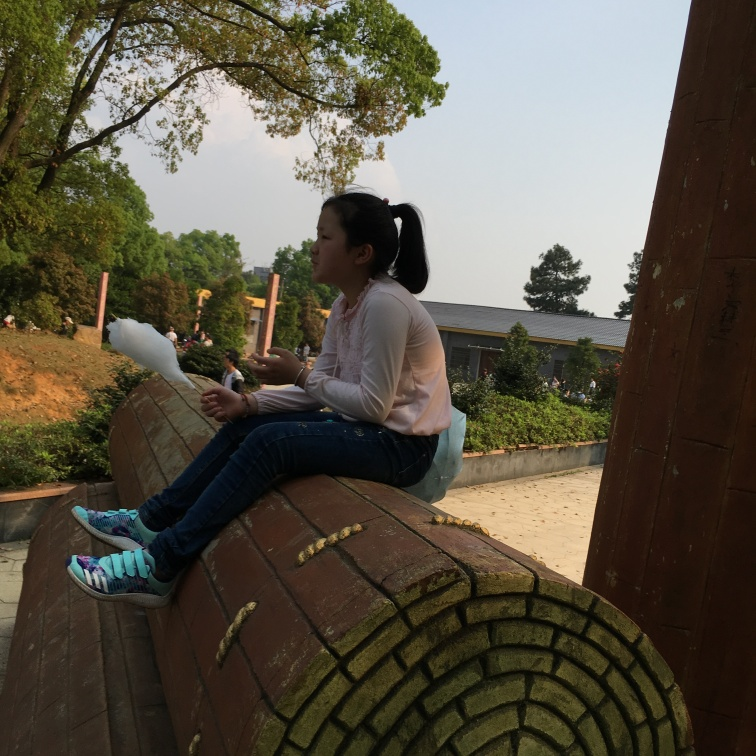What activities might be associated with this location? Given the park-like setting, common activities could include picnicking, leisurely walks, reading, or simply enjoying nature's beauty. The structure the subject is sitting on seems like a perfect spot to rest and observe one's surroundings or engage in quiet reflection. 